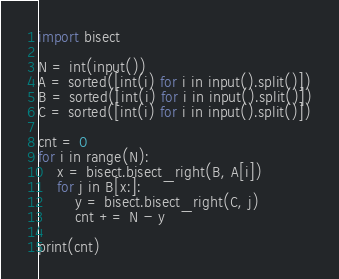Convert code to text. <code><loc_0><loc_0><loc_500><loc_500><_Python_>import bisect

N = int(input())
A = sorted([int(i) for i in input().split()])
B = sorted([int(i) for i in input().split()])
C = sorted([int(i) for i in input().split()])

cnt = 0
for i in range(N):
    x = bisect.bisect_right(B, A[i])
    for j in B[x:]:
        y = bisect.bisect_right(C, j)
        cnt += N - y
        
print(cnt)</code> 